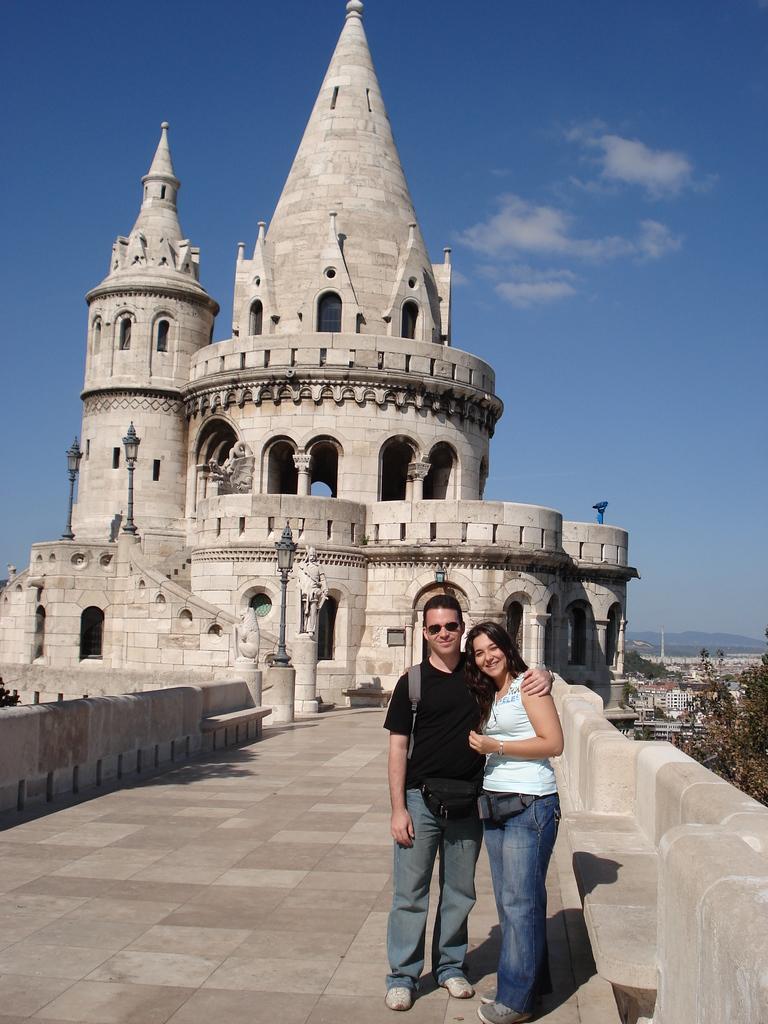Could you give a brief overview of what you see in this image? In this image I see a man and a woman who are standing and I see that both of them are smiling and I see the path. In the background I see the building and I see few light poles and I see a sculpture over here. I can also see few more buildings over here and I see the trees and I see the sky. 